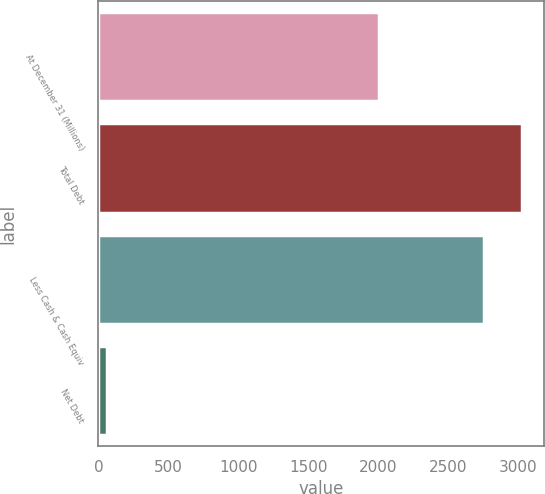<chart> <loc_0><loc_0><loc_500><loc_500><bar_chart><fcel>At December 31 (Millions)<fcel>Total Debt<fcel>Less Cash & Cash Equiv<fcel>Net Debt<nl><fcel>2004<fcel>3032.7<fcel>2757<fcel>64<nl></chart> 